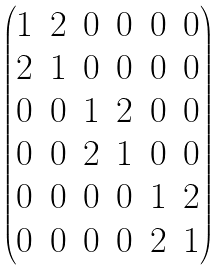Convert formula to latex. <formula><loc_0><loc_0><loc_500><loc_500>\begin{pmatrix} 1 & 2 & 0 & 0 & 0 & 0 \\ 2 & 1 & 0 & 0 & 0 & 0 \\ 0 & 0 & 1 & 2 & 0 & 0 \\ 0 & 0 & 2 & 1 & 0 & 0 \\ 0 & 0 & 0 & 0 & 1 & 2 \\ 0 & 0 & 0 & 0 & 2 & 1 \end{pmatrix}</formula> 